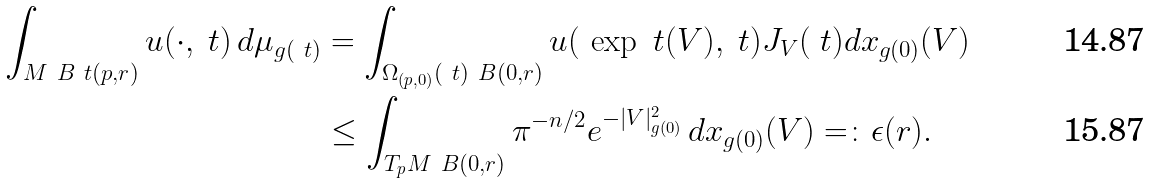Convert formula to latex. <formula><loc_0><loc_0><loc_500><loc_500>\int _ { M \ \L B _ { \ } t ( p , r ) } u ( \cdot , \ t ) \, d \mu _ { g ( \ t ) } & = \int _ { \Omega _ { ( p , 0 ) } ( \ t ) \ B ( 0 , r ) } u ( \L \, \exp _ { \ } t ( V ) , \ t ) \L J _ { V } ( \ t ) d x _ { g ( 0 ) } ( V ) \\ & \leq \int _ { T _ { p } M \ B ( 0 , r ) } \pi ^ { - n / 2 } e ^ { - | V | _ { g ( 0 ) } ^ { 2 } } \, d x _ { g ( 0 ) } ( V ) = \colon \epsilon ( r ) .</formula> 